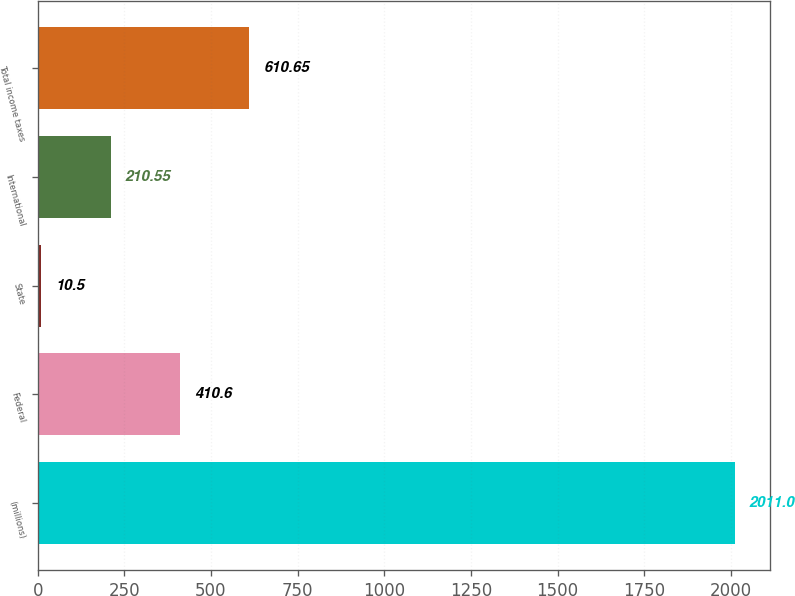<chart> <loc_0><loc_0><loc_500><loc_500><bar_chart><fcel>(millions)<fcel>Federal<fcel>State<fcel>International<fcel>Total income taxes<nl><fcel>2011<fcel>410.6<fcel>10.5<fcel>210.55<fcel>610.65<nl></chart> 